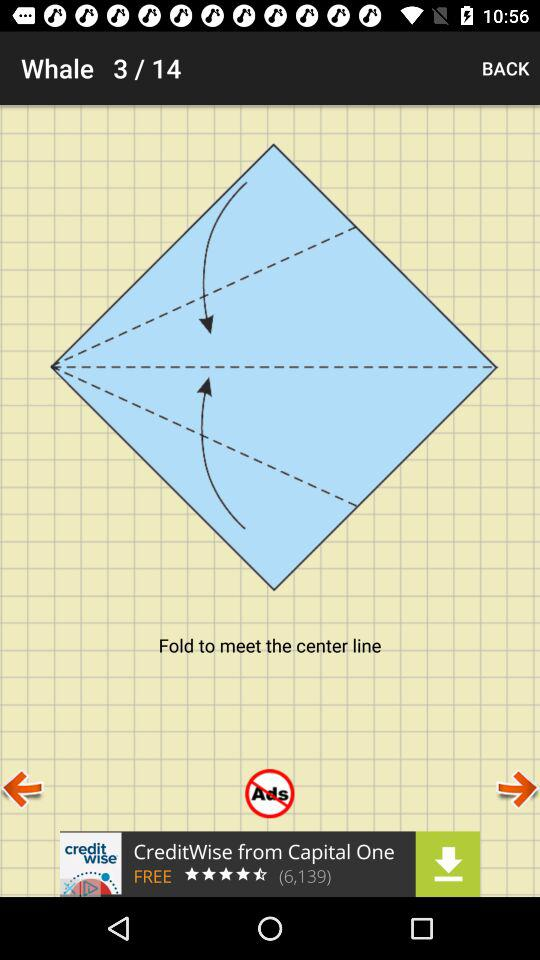Which slide am I on? You are on slide 3. 